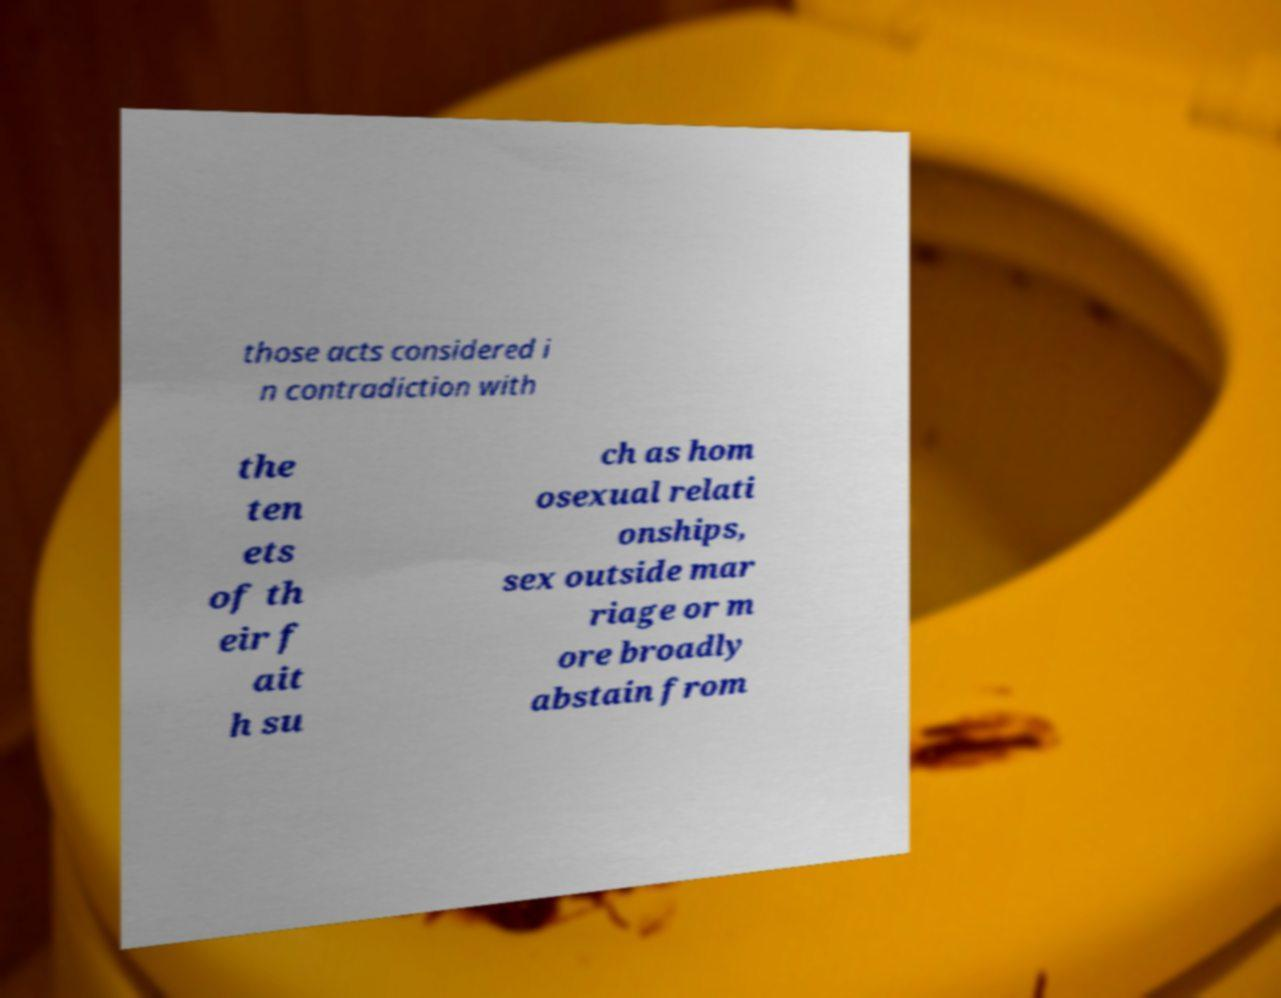For documentation purposes, I need the text within this image transcribed. Could you provide that? those acts considered i n contradiction with the ten ets of th eir f ait h su ch as hom osexual relati onships, sex outside mar riage or m ore broadly abstain from 